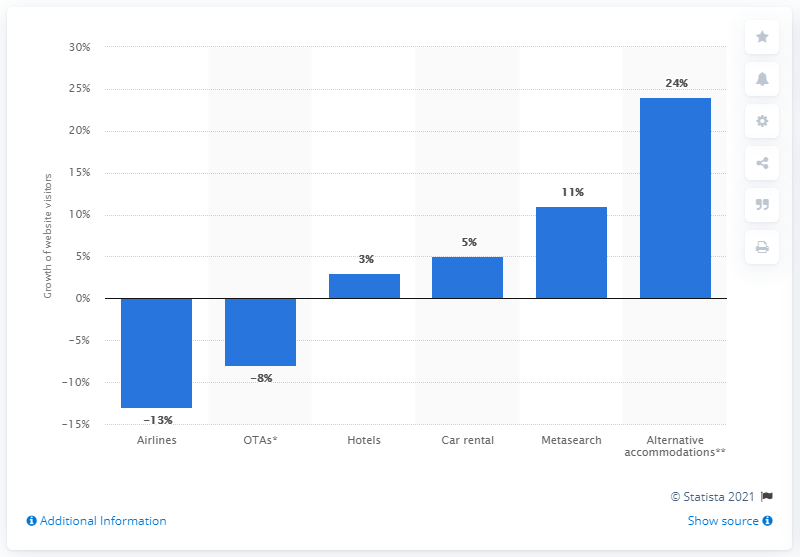Outline some significant characteristics in this image. In 2014, car rental websites received approximately 5% of their unique visitors. 